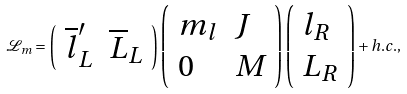<formula> <loc_0><loc_0><loc_500><loc_500>\mathcal { L } _ { m } = \left ( \begin{array} { l l } \overline { l } ^ { \prime } _ { L } & \overline { L } _ { L } \end{array} \right ) \left ( \begin{array} { l l } m _ { l } & J \\ 0 & M \end{array} \right ) \left ( \begin{array} { l } l _ { R } \\ L _ { R } \end{array} \right ) + h . c . ,</formula> 